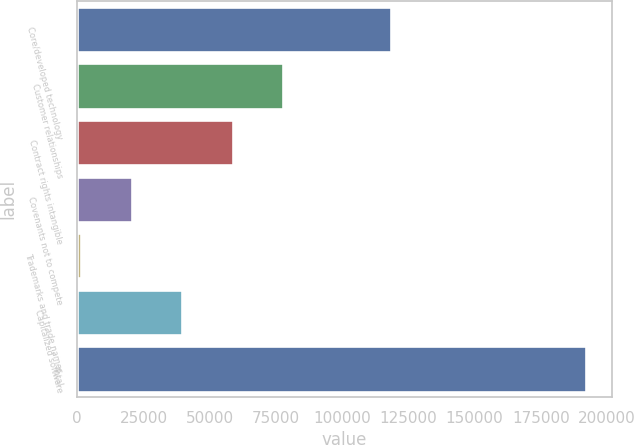Convert chart. <chart><loc_0><loc_0><loc_500><loc_500><bar_chart><fcel>Core/developed technology<fcel>Customer relationships<fcel>Contract rights intangible<fcel>Covenants not to compete<fcel>Trademarks and trade names<fcel>Capitalized software<fcel>Total<nl><fcel>118587<fcel>77786.2<fcel>58724.9<fcel>20602.3<fcel>1541<fcel>39663.6<fcel>192154<nl></chart> 